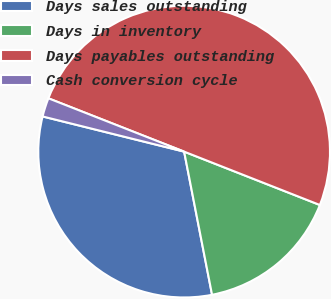Convert chart to OTSL. <chart><loc_0><loc_0><loc_500><loc_500><pie_chart><fcel>Days sales outstanding<fcel>Days in inventory<fcel>Days payables outstanding<fcel>Cash conversion cycle<nl><fcel>31.94%<fcel>15.97%<fcel>50.0%<fcel>2.08%<nl></chart> 